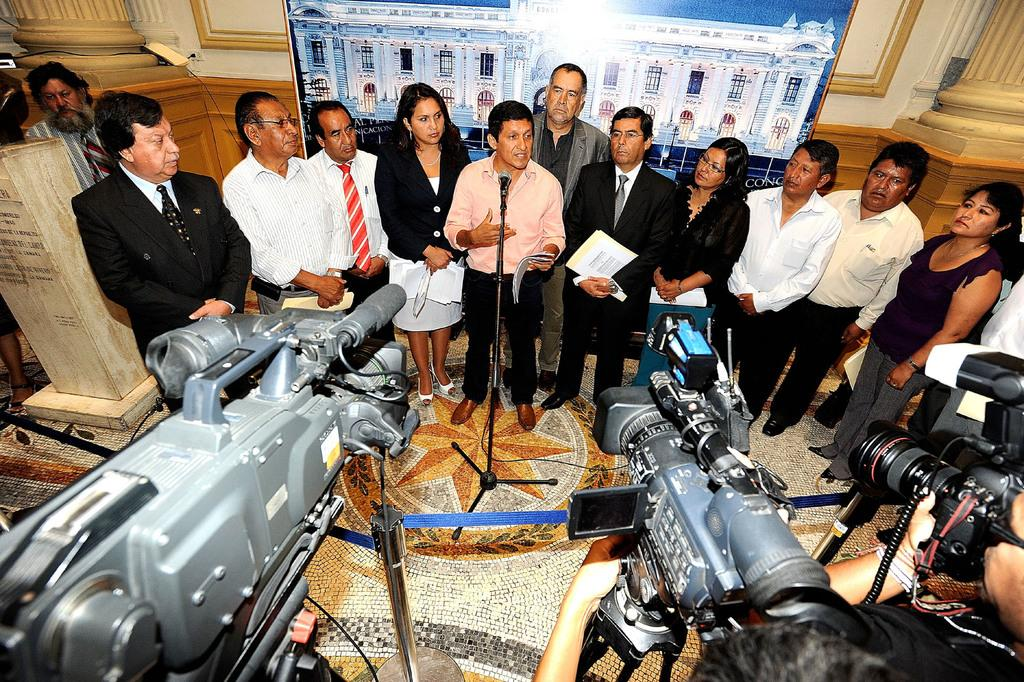What objects are located at the bottom of the image? There are cameras at the bottom of the image. What can be seen in the middle of the image? There are people standing in the middle of the image, and a microphone is also present. What is visible in the background of the image? There is a wall in the background of the image, and a frame is mounted on the wall. How many dogs are sitting on the frame in the image? There are no dogs present in the image; it features cameras, people, a microphone, a wall, and a frame. What type of quilt is draped over the microphone in the image? There is no quilt present in the image; it features cameras, people, a microphone, a wall, and a frame. 